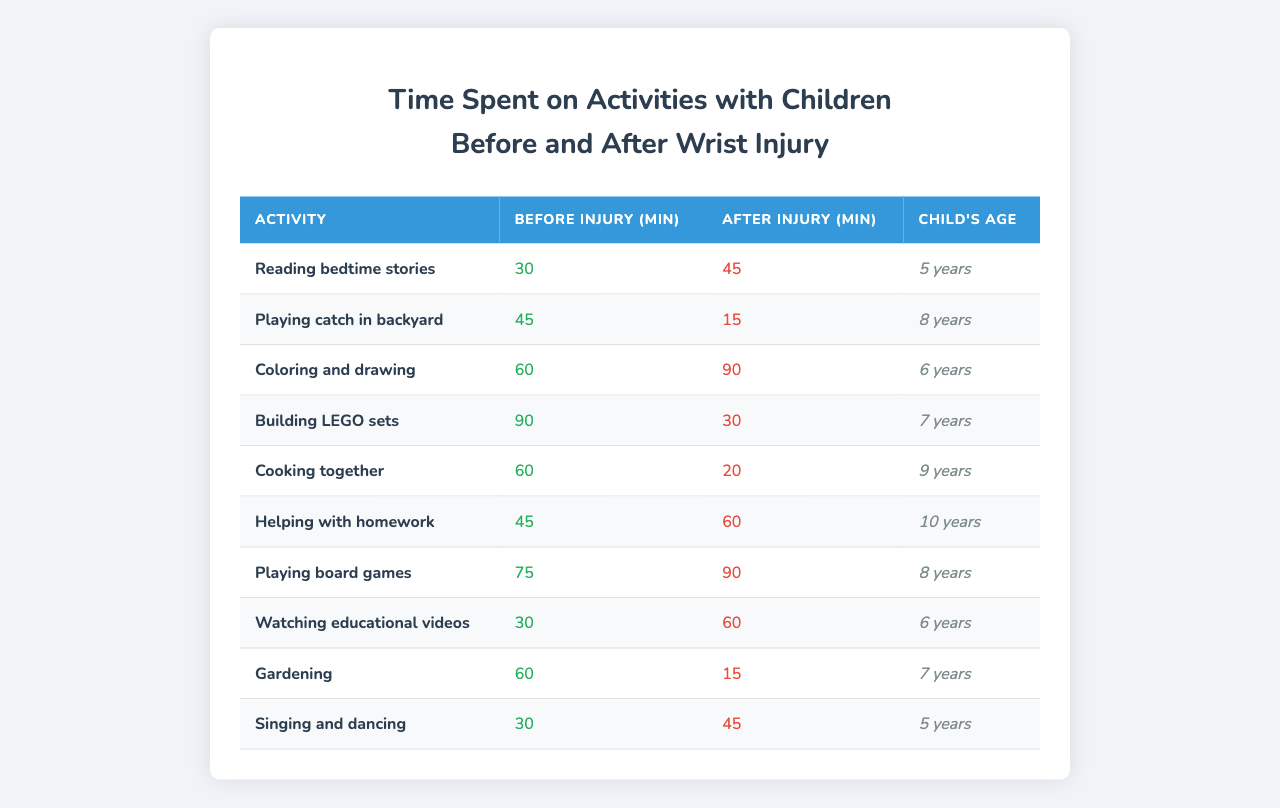What activity had the longest time spent before the wrist injury? By inspecting the table, the "Building LEGO sets" activity had 90 minutes listed for before the injury, which is the highest duration compared to other activities.
Answer: 90 minutes What was the time difference for "Playing catch in backyard" before and after the injury? For "Playing catch in backyard," the time before the injury was 45 minutes and after the injury was 15 minutes. The difference is 45 - 15 = 30 minutes.
Answer: 30 minutes Did the time spent on "Gardening" increase or decrease after the injury? The time spent on "Gardening" before the injury was 60 minutes, and after the injury, it decreased to 15 minutes. Therefore, it decreased after the injury.
Answer: Decreased What was the average time spent on activities after the injury across all activities? To find the average time spent after the injury, we first sum the after injury minutes: (45 + 15 + 90 + 30 + 20 + 60 + 90 + 60 + 15 + 45) =  420. There are 10 activities, so the average is 420/10 = 42.
Answer: 42 minutes How many activities increased in duration after the wrist injury? By reviewing the table, "Reading bedtime stories," "Coloring and drawing," "Helping with homework," "Playing board games," and "Watching educational videos" had increased times after the injury, which totals to 5 activities.
Answer: 5 activities Which activity had the greatest increase in time spent? By comparing the differences in time spent before and after the injury, "Coloring and drawing" increased from 60 minutes to 90 minutes, resulting in a 30-minute increase, which is the highest increase among the activities.
Answer: 30 minutes How much time was spent on "Cooking together" before the wrist injury? The table shows that 60 minutes were spent on "Cooking together" before the wrist injury.
Answer: 60 minutes Is it true that "Singing and dancing" had more time spent after the injury than before? "Singing and dancing" had 30 minutes before the injury and 45 minutes after, confirming that the time increased after the wrist injury. Thus, the statement is true.
Answer: True 